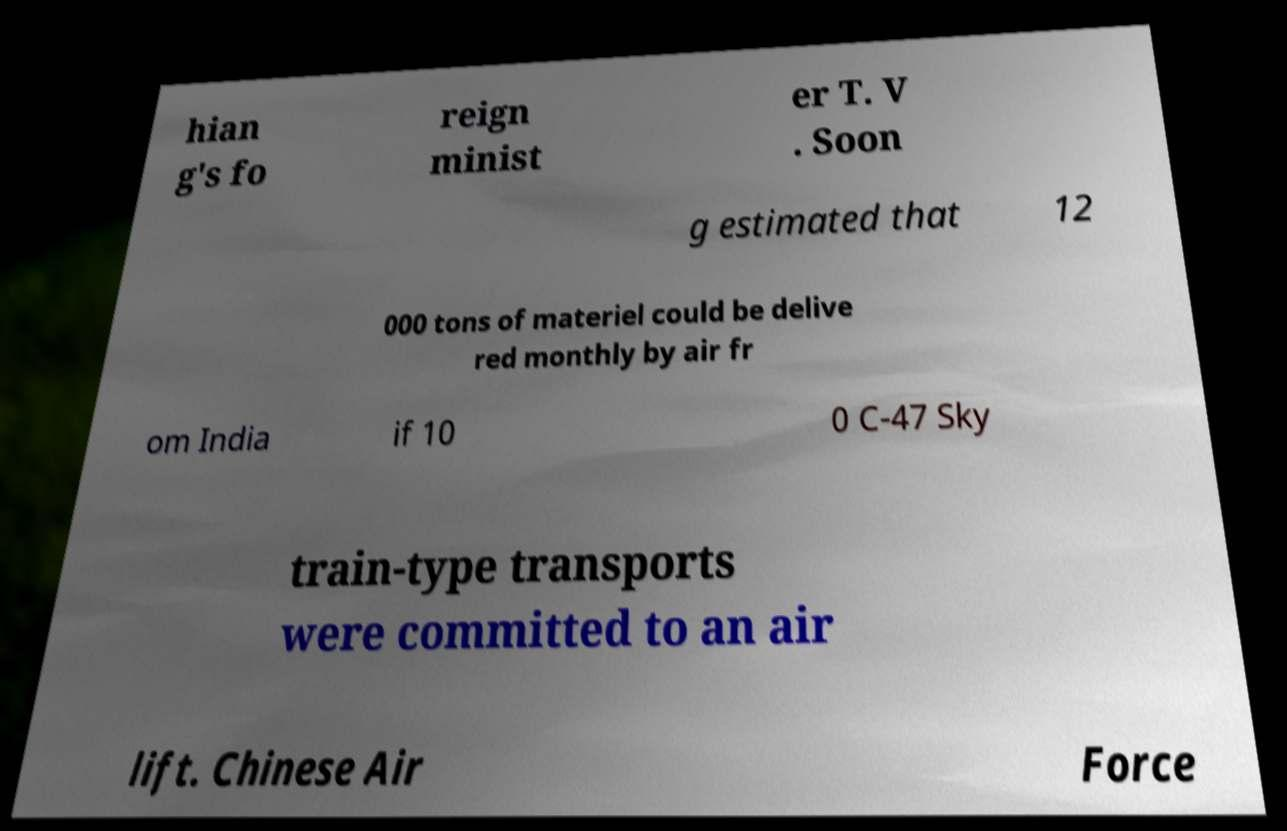Can you read and provide the text displayed in the image?This photo seems to have some interesting text. Can you extract and type it out for me? hian g's fo reign minist er T. V . Soon g estimated that 12 000 tons of materiel could be delive red monthly by air fr om India if 10 0 C-47 Sky train-type transports were committed to an air lift. Chinese Air Force 